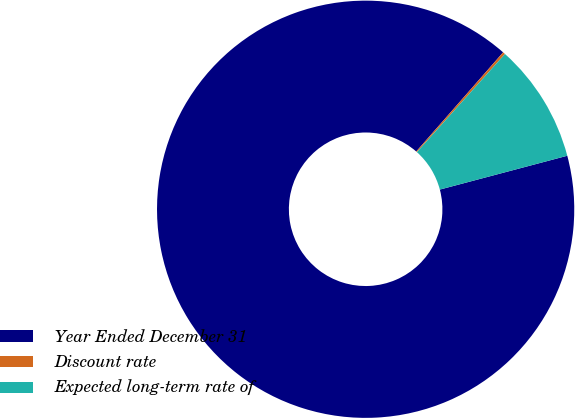<chart> <loc_0><loc_0><loc_500><loc_500><pie_chart><fcel>Year Ended December 31<fcel>Discount rate<fcel>Expected long-term rate of<nl><fcel>90.58%<fcel>0.19%<fcel>9.23%<nl></chart> 